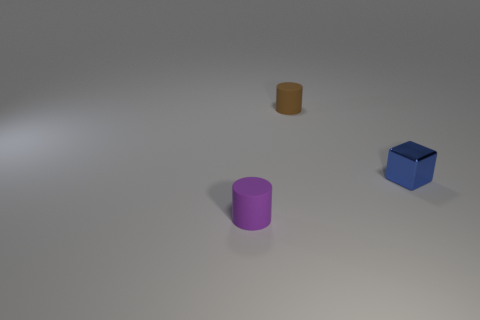There is a blue block that is in front of the tiny brown matte thing; is there a brown matte cylinder that is right of it?
Your answer should be very brief. No. There is a brown object that is the same shape as the purple matte thing; what is it made of?
Offer a terse response. Rubber. There is a matte object on the right side of the tiny purple rubber cylinder; how many small things are in front of it?
Your answer should be very brief. 2. Is there anything else that has the same color as the metal cube?
Provide a short and direct response. No. How many things are tiny brown matte cylinders or small matte objects that are behind the blue shiny object?
Your response must be concise. 1. What material is the thing to the right of the matte cylinder on the right side of the rubber cylinder in front of the tiny brown rubber thing made of?
Provide a succinct answer. Metal. What is the size of the cylinder that is the same material as the brown thing?
Keep it short and to the point. Small. There is a tiny rubber thing that is on the right side of the tiny rubber cylinder that is in front of the brown thing; what color is it?
Provide a short and direct response. Brown. How many small blue objects are made of the same material as the tiny brown object?
Provide a short and direct response. 0. How many rubber objects are tiny purple cylinders or brown things?
Provide a succinct answer. 2. 